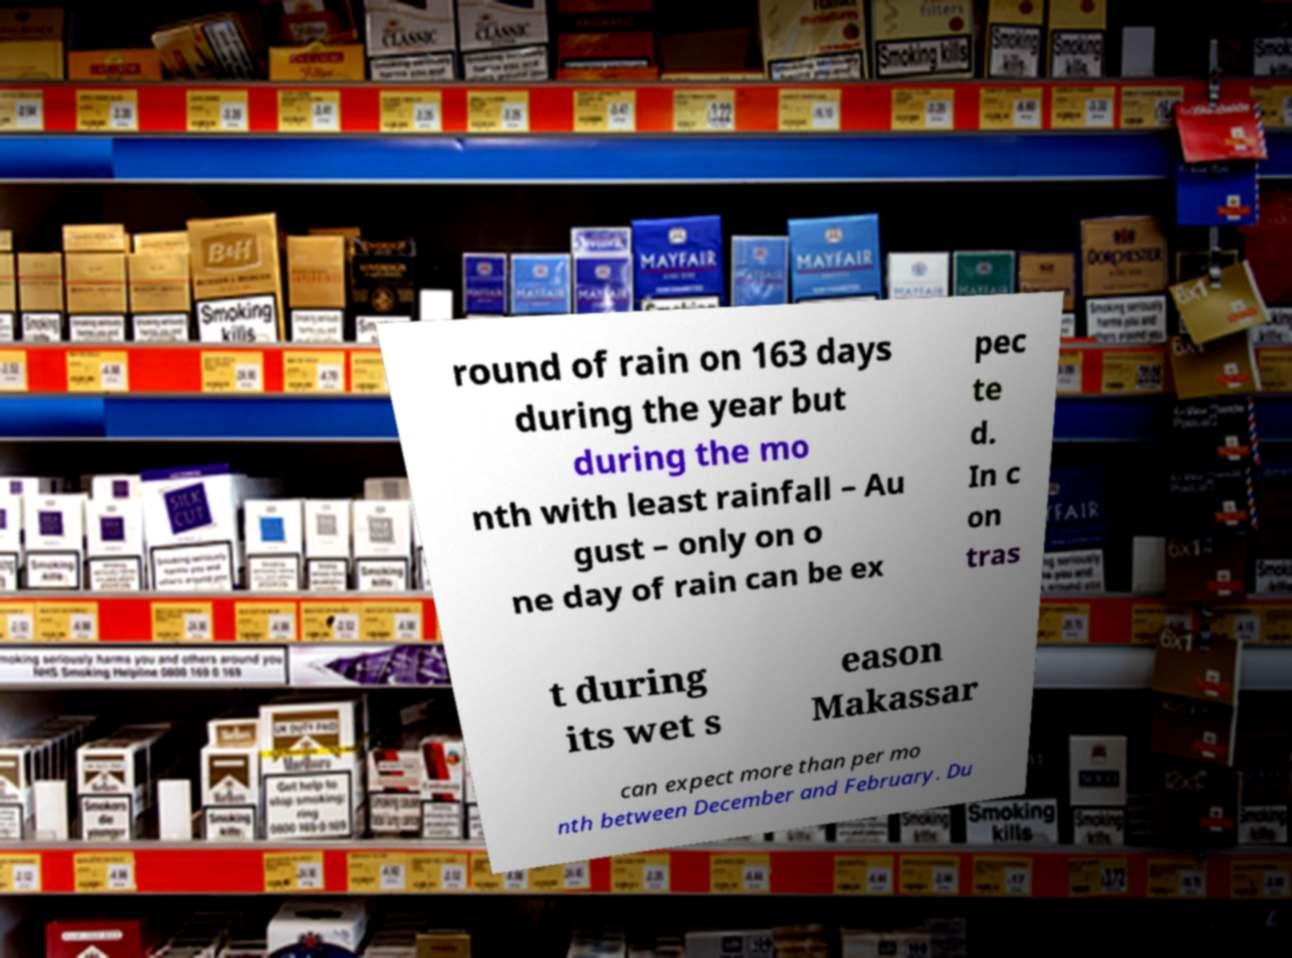Please identify and transcribe the text found in this image. round of rain on 163 days during the year but during the mo nth with least rainfall – Au gust – only on o ne day of rain can be ex pec te d. In c on tras t during its wet s eason Makassar can expect more than per mo nth between December and February. Du 